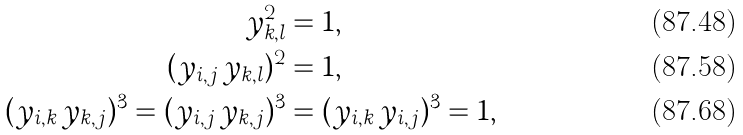Convert formula to latex. <formula><loc_0><loc_0><loc_500><loc_500>y _ { k , l } ^ { 2 } & = 1 , \\ ( y _ { i , j } \, y _ { k , l } ) ^ { 2 } & = 1 , \\ ( y _ { i , k } \, y _ { k , j } ) ^ { 3 } = ( y _ { i , j } \, y _ { k , j } ) ^ { 3 } & = ( y _ { i , k } \, y _ { i , j } ) ^ { 3 } = 1 ,</formula> 